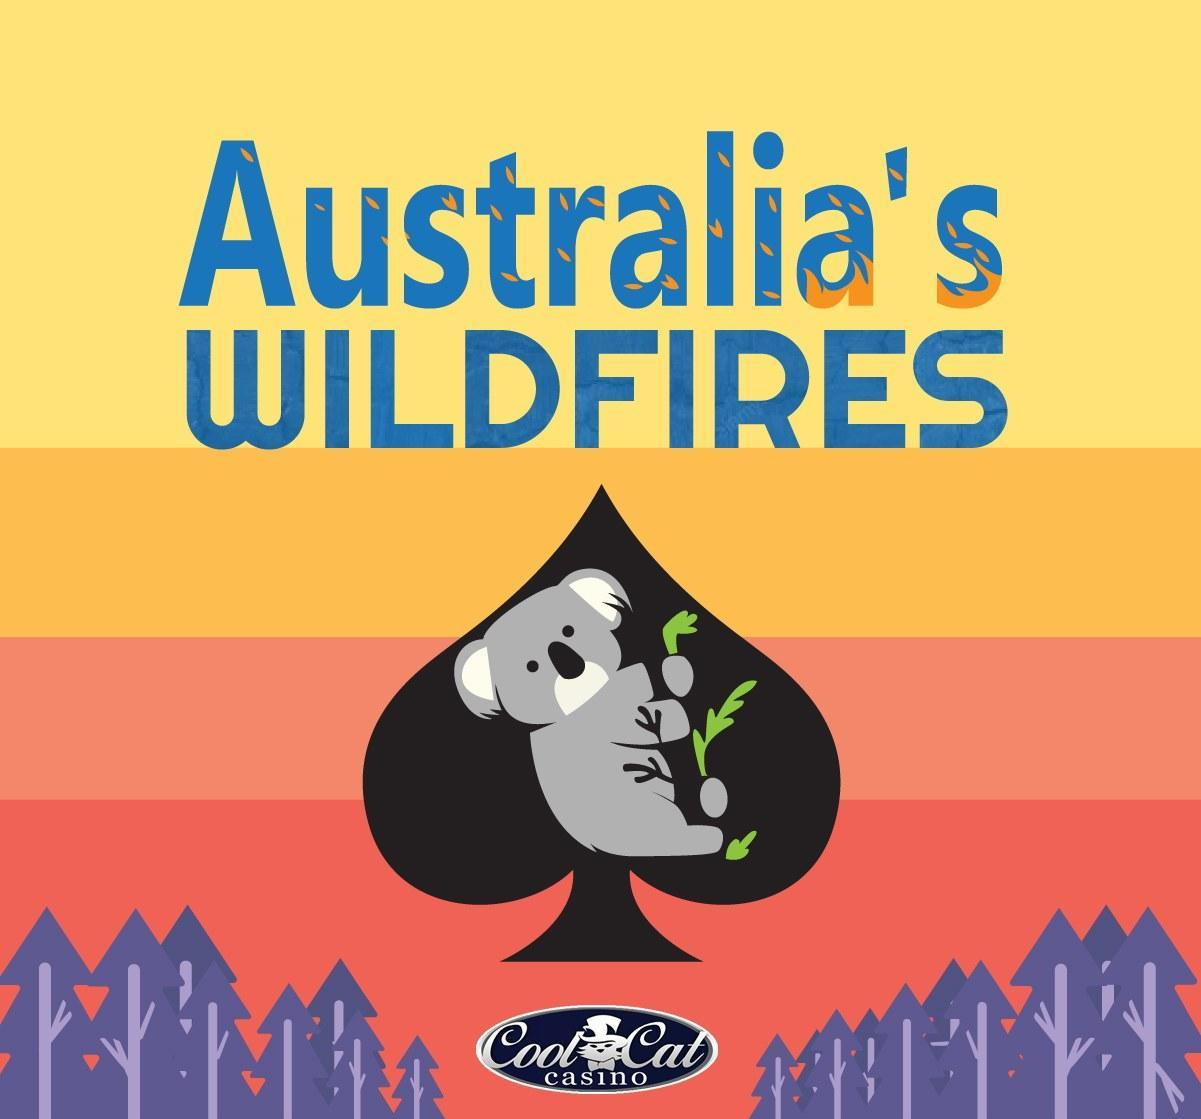Which animal is shown in the info graphic of Australia s Wildfires- kangaroo, lion, teddy bear, elephant?
Answer the question with a short phrase. teddy bear 